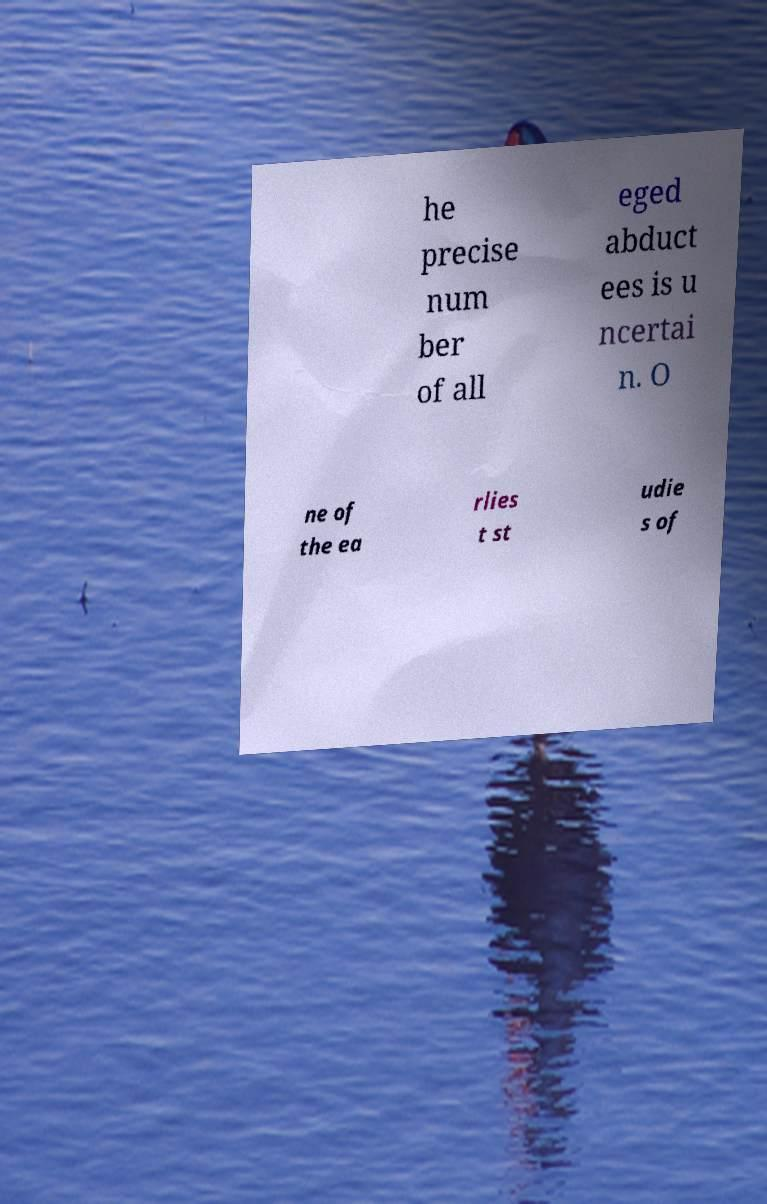Please identify and transcribe the text found in this image. he precise num ber of all eged abduct ees is u ncertai n. O ne of the ea rlies t st udie s of 